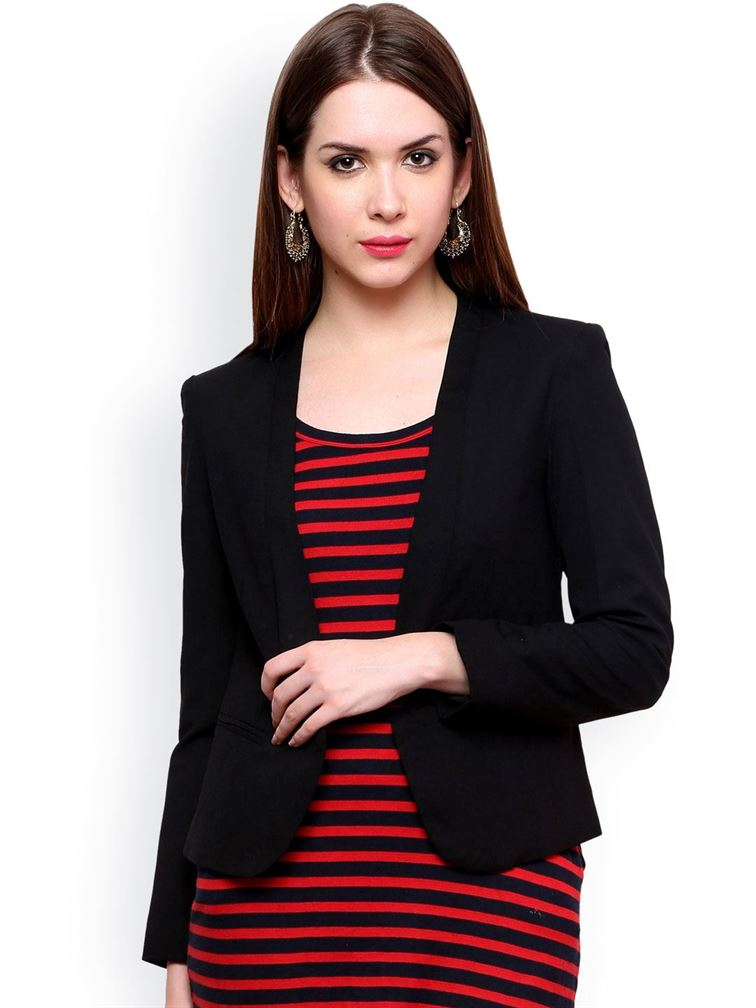What is the woman's profession based on her outfit? The woman in the image is dressed in a professional and fashionable manner, wearing a black blazer over a red and black striped dress. This attire suggests a formal or semi-formal setting, which could imply she works in an office environment, possibly in a business, corporate, or creative field where professional appearance is valued. What kind of event might she be attending? Given her polished and professional outfit, she might be attending a business meeting, a formal work event, or possibly a networking event. The combination of her blazer and dress strikes a balance between professionalism and style, making it suitable for important presentations or social gatherings with professionals. 